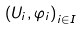Convert formula to latex. <formula><loc_0><loc_0><loc_500><loc_500>\left ( U _ { i } , \varphi _ { i } \right ) _ { i \in I }</formula> 